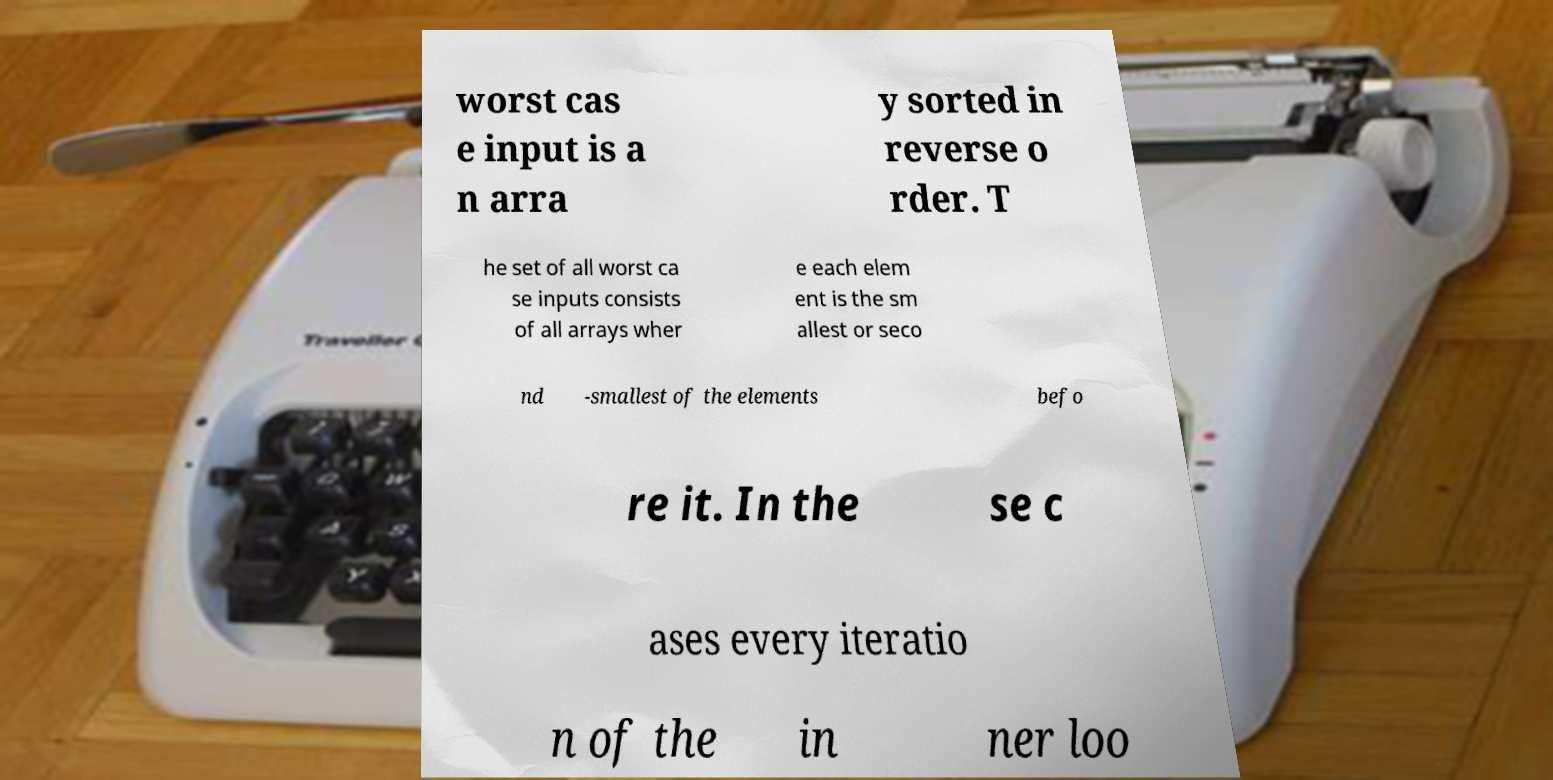What messages or text are displayed in this image? I need them in a readable, typed format. worst cas e input is a n arra y sorted in reverse o rder. T he set of all worst ca se inputs consists of all arrays wher e each elem ent is the sm allest or seco nd -smallest of the elements befo re it. In the se c ases every iteratio n of the in ner loo 